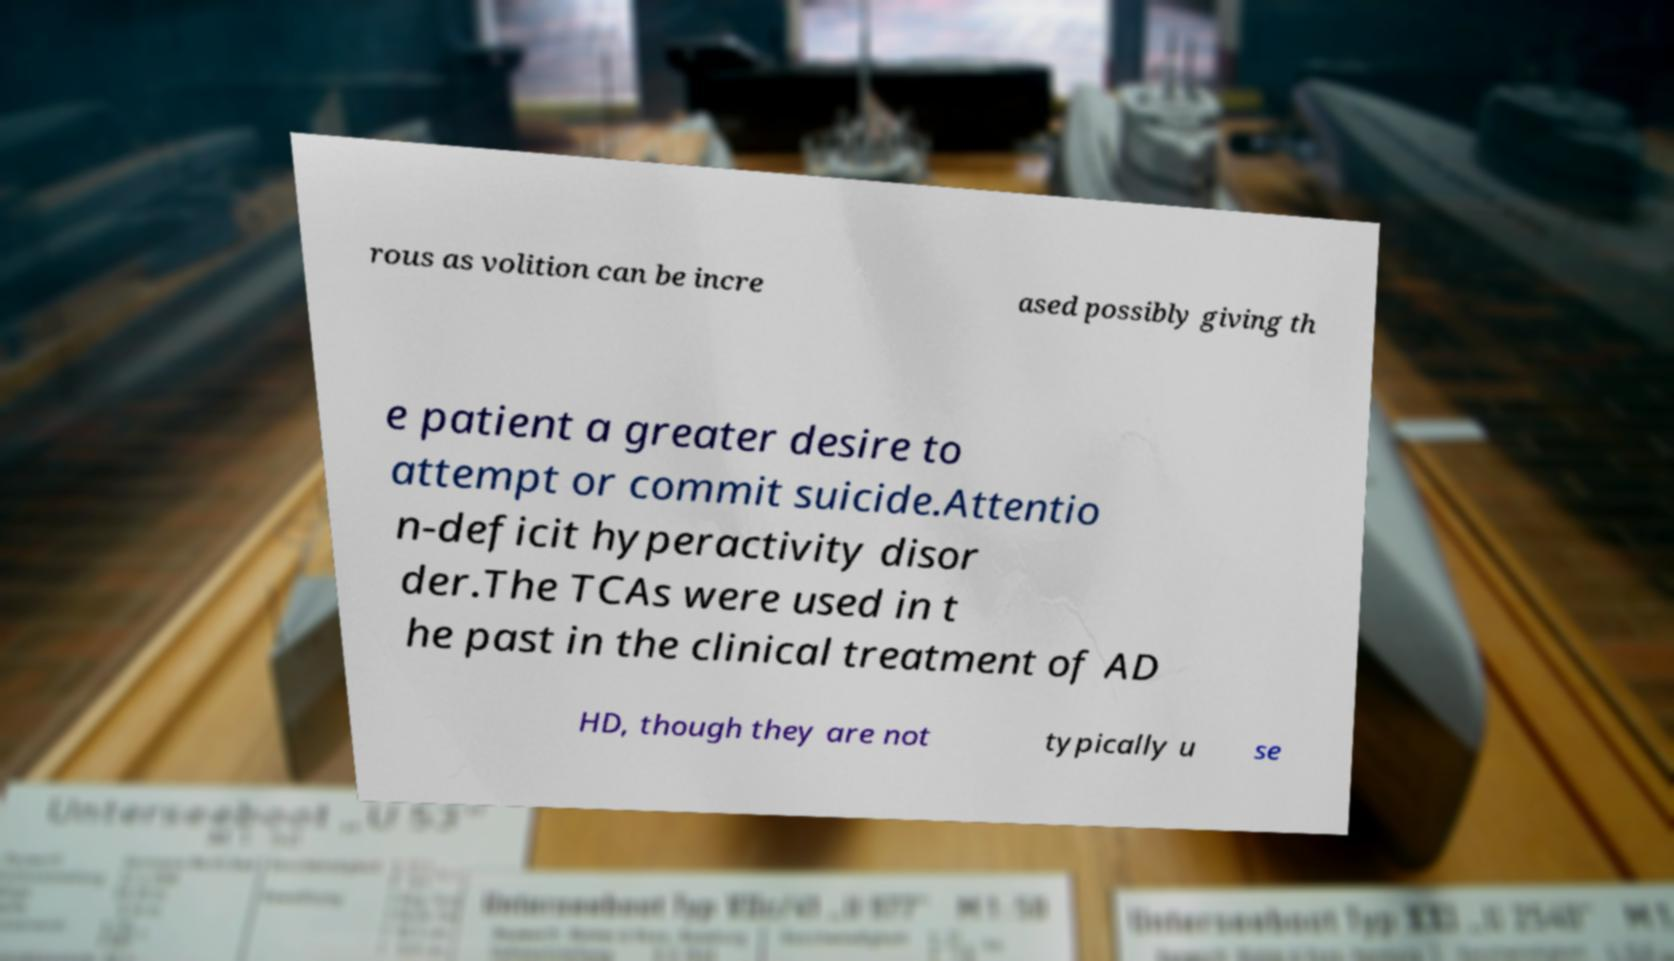There's text embedded in this image that I need extracted. Can you transcribe it verbatim? rous as volition can be incre ased possibly giving th e patient a greater desire to attempt or commit suicide.Attentio n-deficit hyperactivity disor der.The TCAs were used in t he past in the clinical treatment of AD HD, though they are not typically u se 